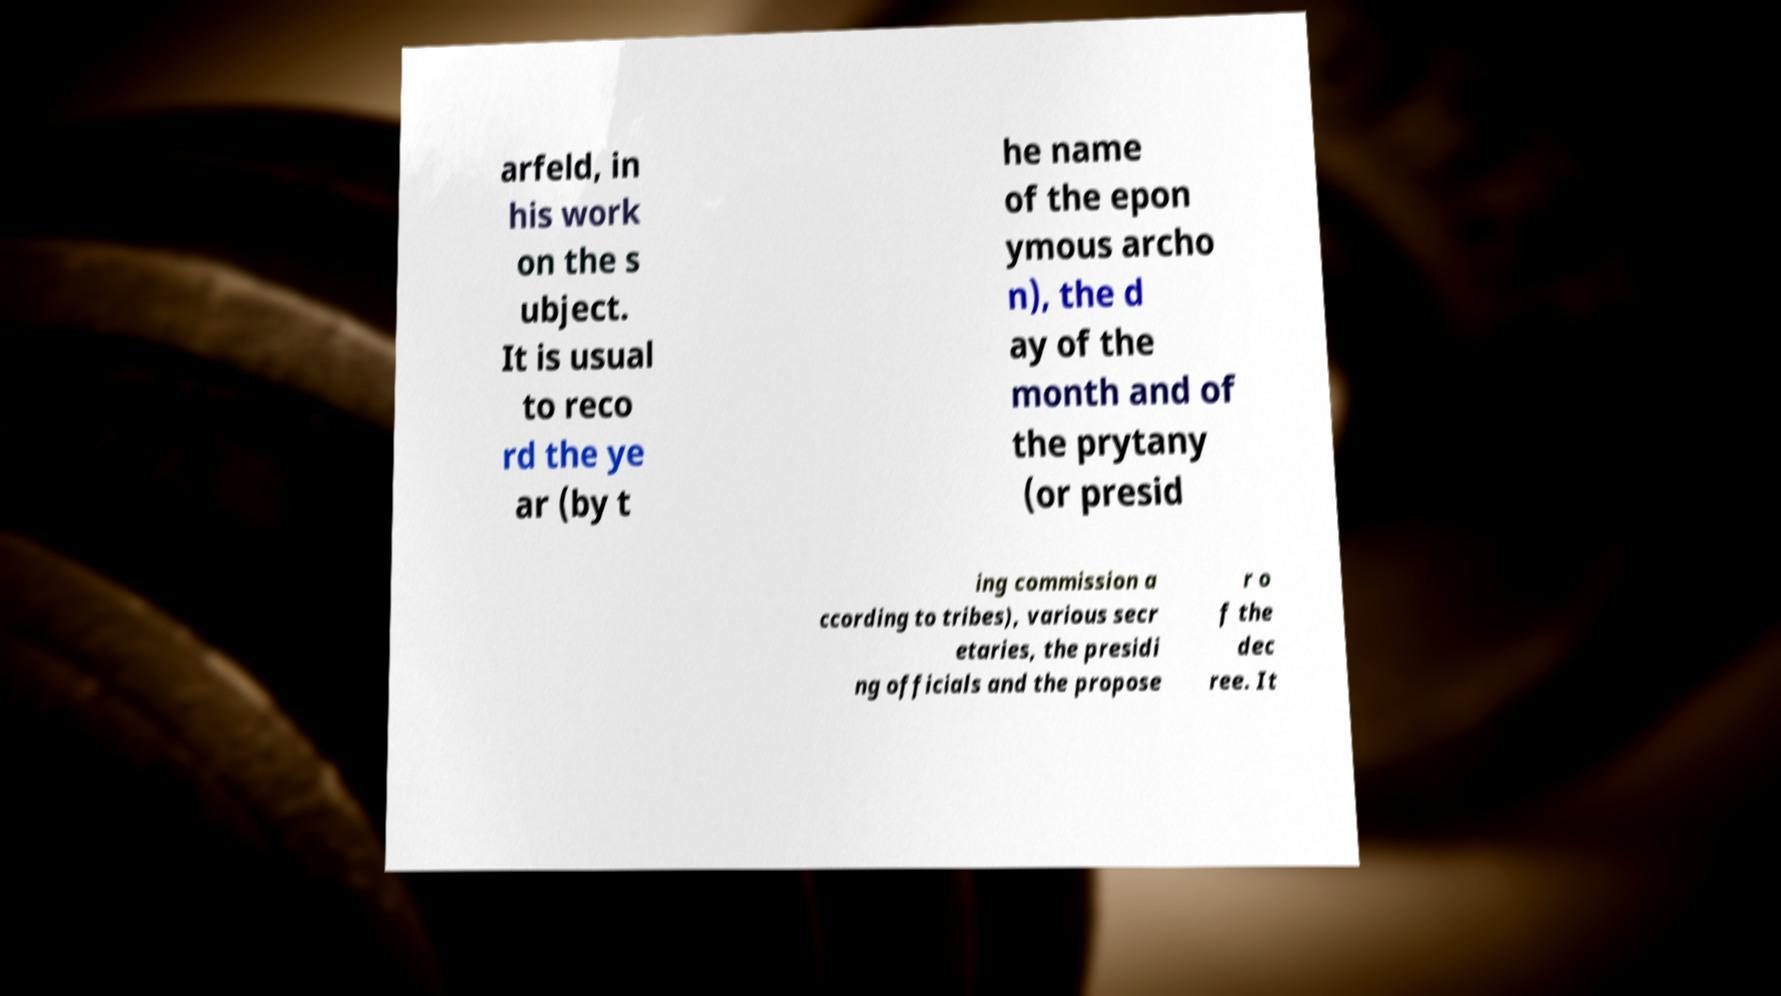For documentation purposes, I need the text within this image transcribed. Could you provide that? arfeld, in his work on the s ubject. It is usual to reco rd the ye ar (by t he name of the epon ymous archo n), the d ay of the month and of the prytany (or presid ing commission a ccording to tribes), various secr etaries, the presidi ng officials and the propose r o f the dec ree. It 